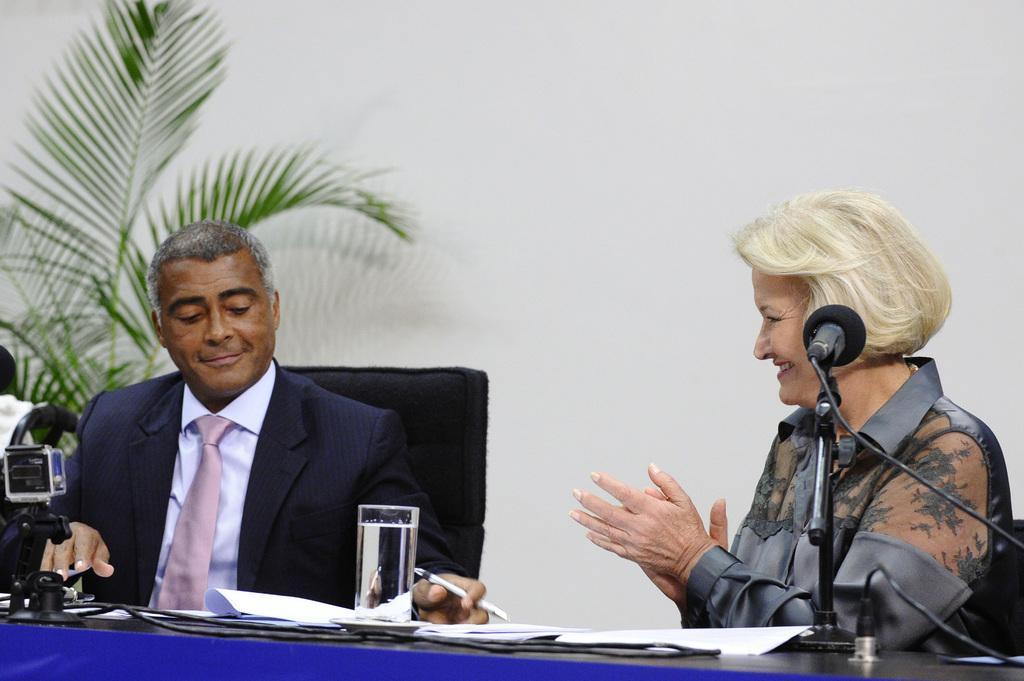Please provide a concise description of this image. In this image we can see a man and a woman are sitting on the black color chairs. In front of them, we can see a table. On the table, we can see mics, wired, glass and papers. In the background, we can see a plant and a wall. The man is holding a pen in his hand. 